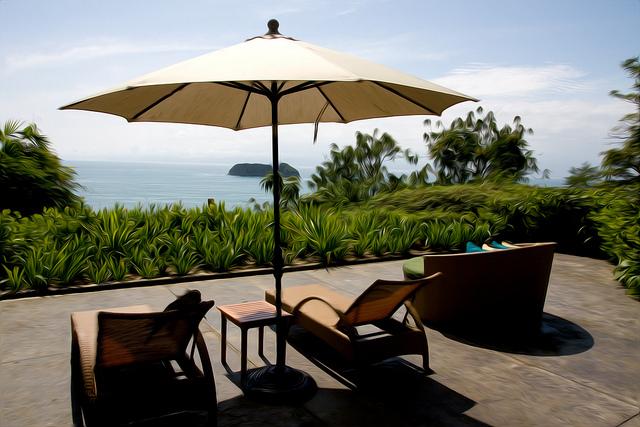Is the round chair for more than one person?
Be succinct. Yes. How many chairs are there?
Quick response, please. 3. What is the view from the chairs?
Short answer required. Water. What color is the umbrella?
Keep it brief. Tan. Is this a beach?
Concise answer only. Yes. Is the weather good enough to take a sunbath on one of these chairs?
Write a very short answer. Yes. How many chairs can be seen?
Quick response, please. 3. 